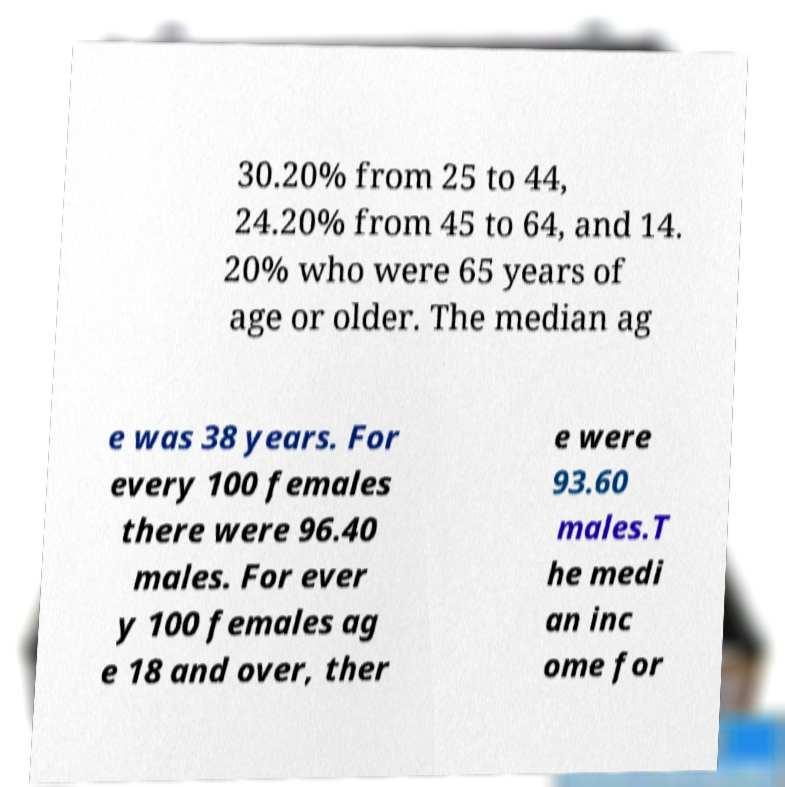Please read and relay the text visible in this image. What does it say? 30.20% from 25 to 44, 24.20% from 45 to 64, and 14. 20% who were 65 years of age or older. The median ag e was 38 years. For every 100 females there were 96.40 males. For ever y 100 females ag e 18 and over, ther e were 93.60 males.T he medi an inc ome for 